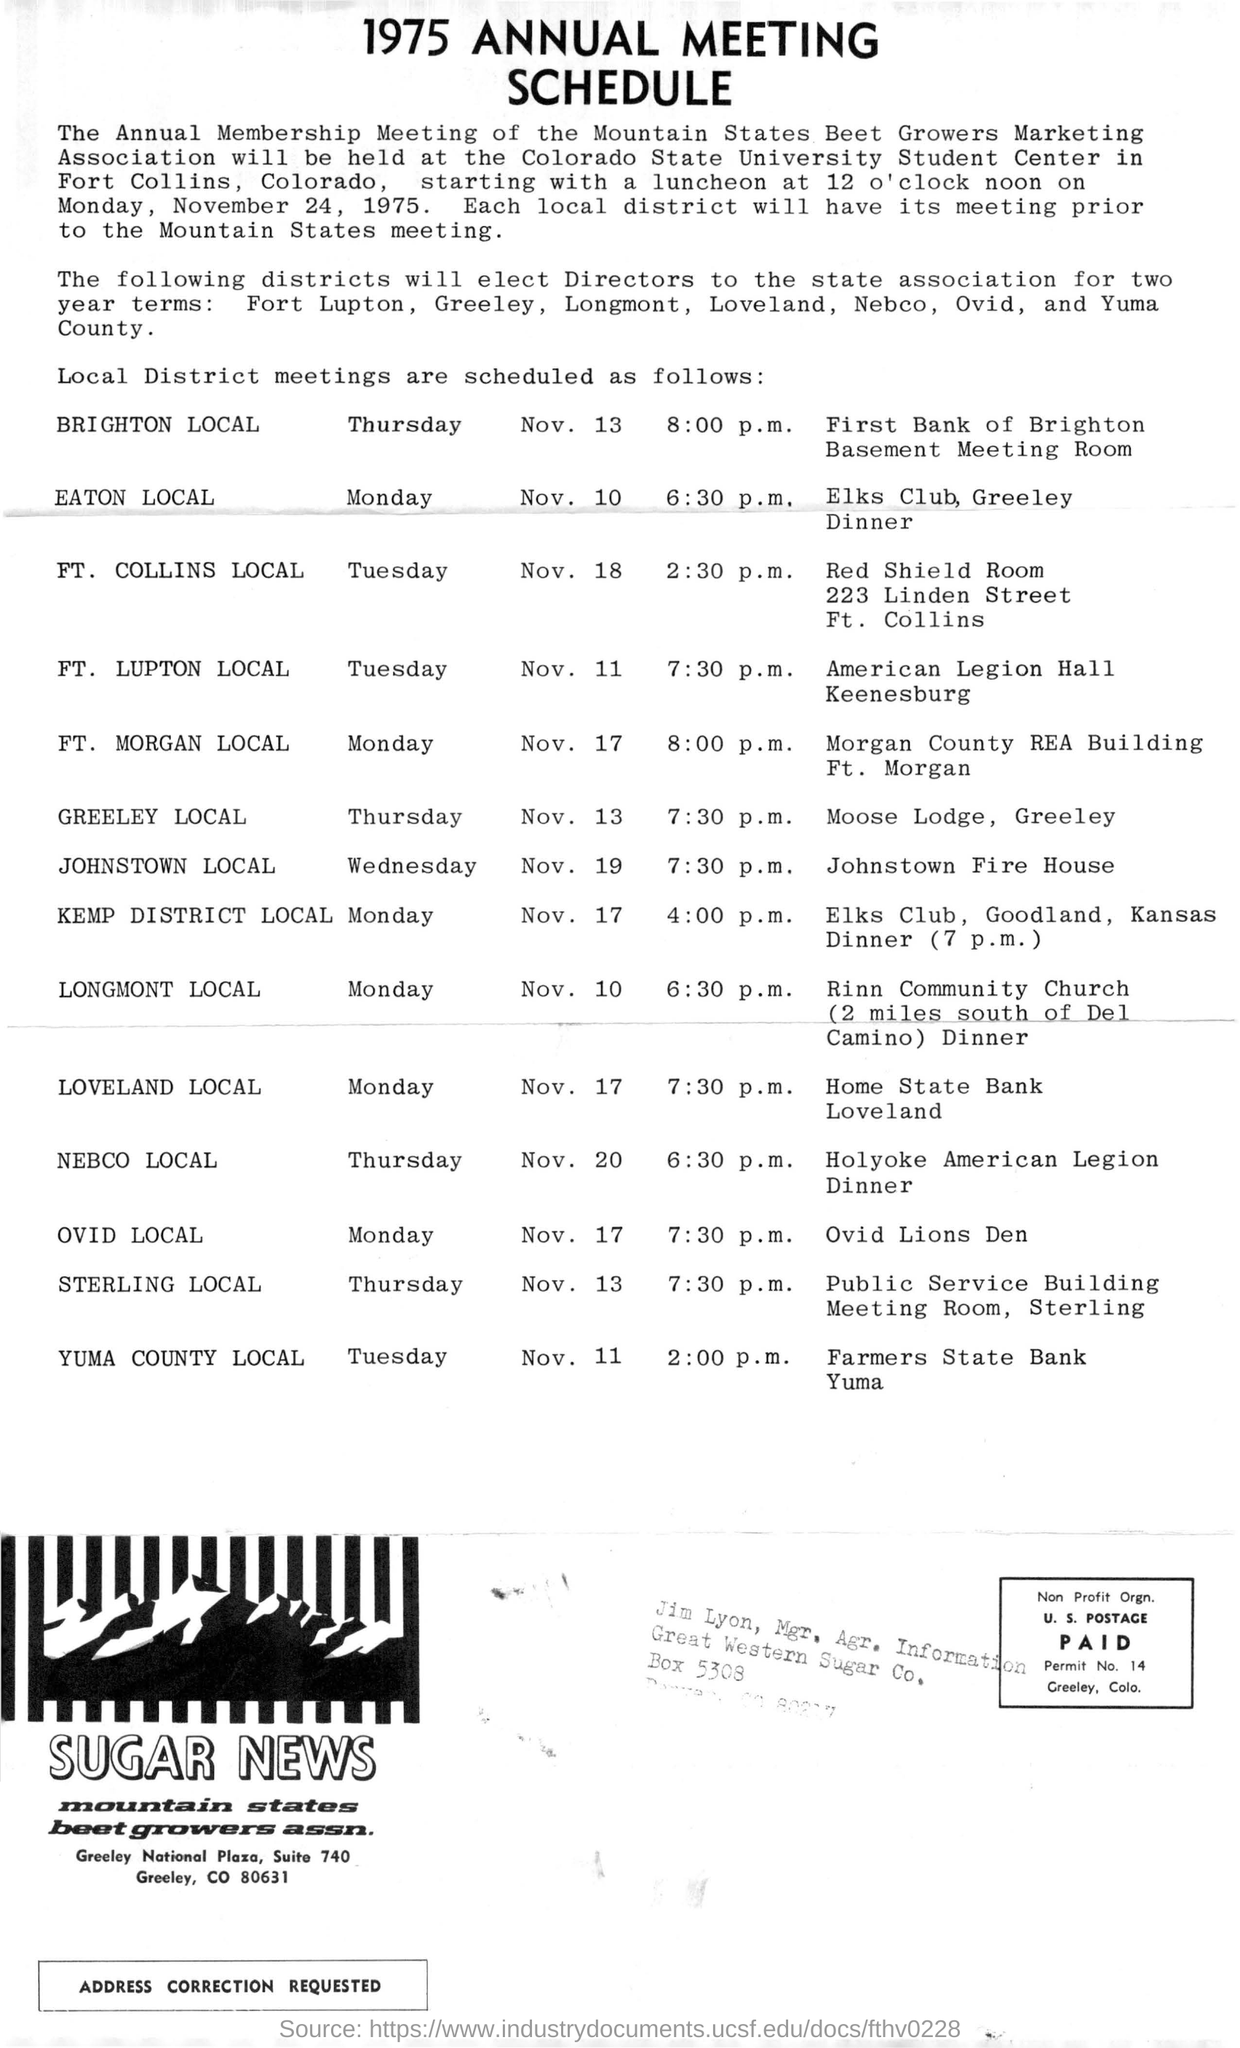Where is the Annual Membership Meeting of the Mountain States Beet Growers Marketing Association held at?
Keep it short and to the point. COLORADO STATE UNIVERSITY STUDENT CENTER. Where is Colorado State University Student Center located at?
Your response must be concise. FORT COLLINS, COLORADO. What type of schedule is given here?
Keep it short and to the point. 1975 ANNUAL MEETING SCHEDULE. 